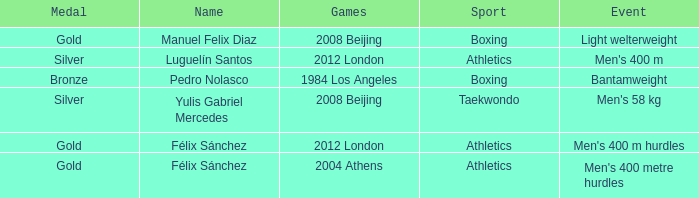Which Medal had a Name of félix sánchez, and a Games of 2012 london? Gold. 